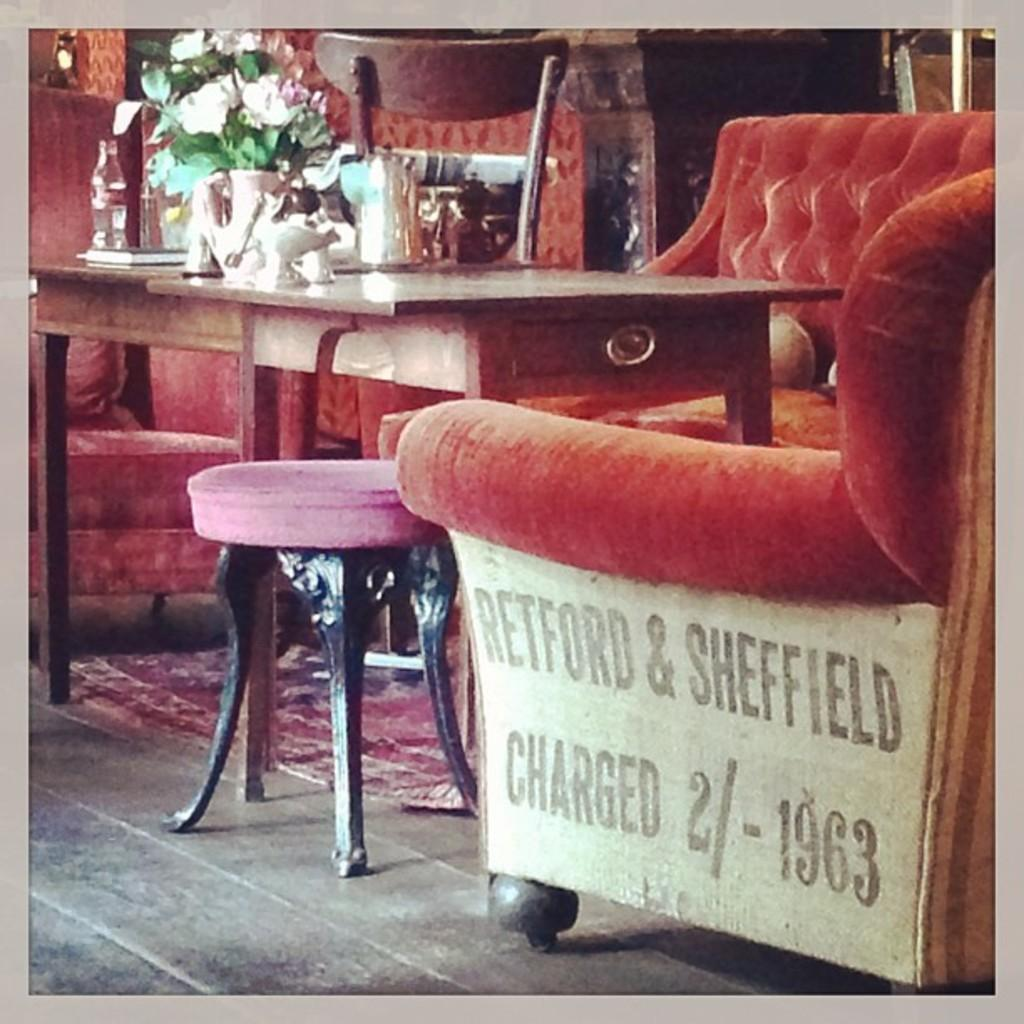What color is the sofa in the image? The sofa in the image is red. What is located in front of the sofa? There is a table in front of the sofa. What can be seen on the table? There is a flower vase and bottles on the table. What additional piece of furniture is present beside the sofa? There is a small stool beside the sofa. How many boys are sitting on the sofa in the image? There are no boys present in the image; it only shows a red sofa, a table, a flower vase, bottles, and a small stool. 